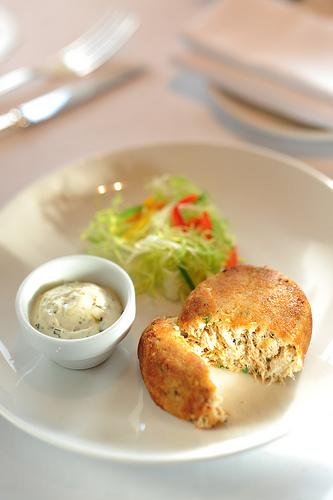Count the number of objects related to silverware present in the image. There are 2 objects: a fork and a butter knife. Provide a short and concise caption for the image. Crab cake with salad and tartar sauce on a white plate in a restaurant. What type of sauce is served with the crab cake in the image? A small white bowl of tartar sauce with flecks of pickle. Describe the salad shown in the image. The shredded salad consists of various greens and shredded red pepper bits. Describe the environment in which the meal is served based on the image. The meal is served in a restaurant, with blurred silverware and napkins on the table. Analyze the texture of the crab cake by noting the breading and any visible ingredients. The crab cake has a brown breading, with green seasoning and visible pieces of meat inside. Discuss the quality of this meal according to the visual presentation. The meal appears visually appealing with neatly arranged components and a hint of green seasoning in the crab cake. How many food items are present on the plate in the image? There are 3 food items: crab cake, shredded salad, and a small bowl of tartar sauce. Infer the sentiment or mood of the image based on the presentation and elements present in the scene. The image suggests a cozy, inviting atmosphere with a focus on enjoying a delicious and well-prepared meal. What is the primary dish featured in the image? Crab cake on a plate. 